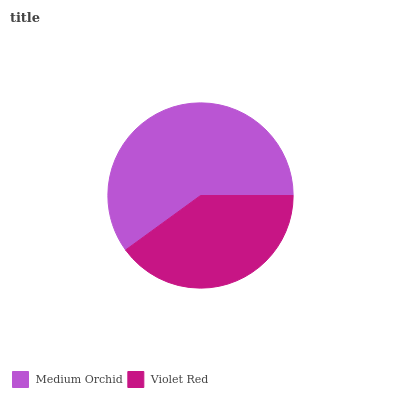Is Violet Red the minimum?
Answer yes or no. Yes. Is Medium Orchid the maximum?
Answer yes or no. Yes. Is Violet Red the maximum?
Answer yes or no. No. Is Medium Orchid greater than Violet Red?
Answer yes or no. Yes. Is Violet Red less than Medium Orchid?
Answer yes or no. Yes. Is Violet Red greater than Medium Orchid?
Answer yes or no. No. Is Medium Orchid less than Violet Red?
Answer yes or no. No. Is Medium Orchid the high median?
Answer yes or no. Yes. Is Violet Red the low median?
Answer yes or no. Yes. Is Violet Red the high median?
Answer yes or no. No. Is Medium Orchid the low median?
Answer yes or no. No. 